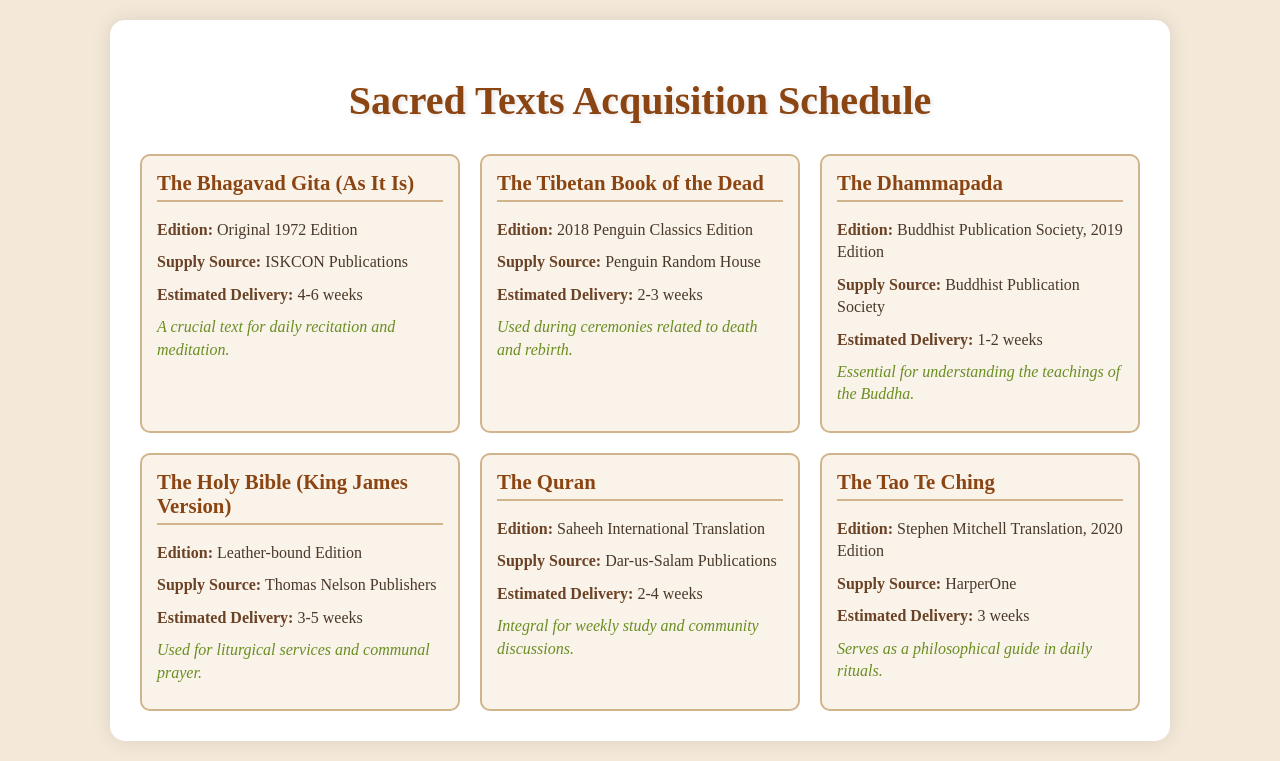What is the title of the first text listed? The title of the first text is found in the first text item of the schedule, which is The Bhagavad Gita (As It Is).
Answer: The Bhagavad Gita (As It Is) Who is the supply source for The Dhammapada? The supply source for The Dhammapada is listed under its text item, which states it is from Buddhist Publication Society.
Answer: Buddhist Publication Society What is the estimated delivery time for The Quran? The estimated delivery time for The Quran is specified in the text item for this book, which indicates 2-4 weeks.
Answer: 2-4 weeks What is the edition of The Holy Bible? The edition of The Holy Bible is described in the text item, which specifies it is a Leather-bound Edition.
Answer: Leather-bound Edition Which text has the shortest estimated delivery time? The text with the shortest estimated delivery time is identified by comparing the delivery times, with The Dhammapada as 1-2 weeks.
Answer: The Dhammapada What is the main use of The Tibetan Book of the Dead? The main use of The Tibetan Book of the Dead can be inferred from the notes section of its text item, which states it's used during ceremonies related to death and rebirth.
Answer: Ceremonies related to death and rebirth Who is the publisher for The Tao Te Ching? The publisher for The Tao Te Ching can be found in its text item, which names HarperOne as the supply source.
Answer: HarperOne What is the purpose of The Quran in the community? The purpose of The Quran is outlined in the notes of its text item, indicating it is integral for weekly study and community discussions.
Answer: Weekly study and community discussions What edition does The Bhagavad Gita reference? The edition of The Bhagavad Gita is mentioned in the text item as the Original 1972 Edition.
Answer: Original 1972 Edition 